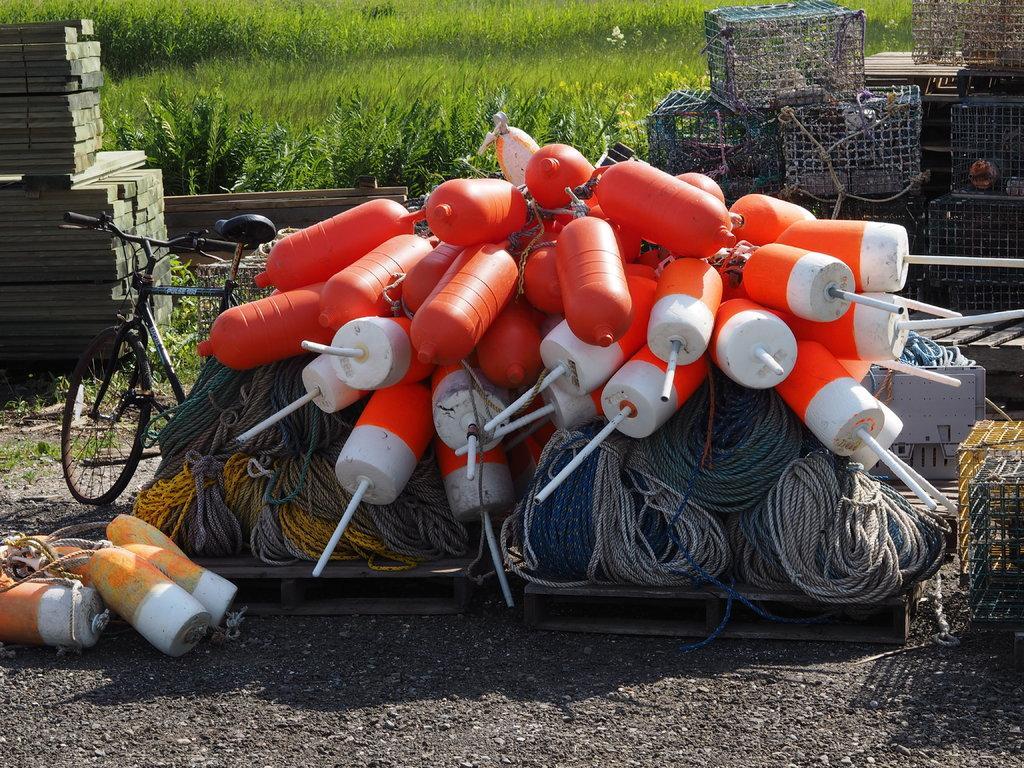Describe this image in one or two sentences. In the foreground of this image, there are few objects, ropes, mesh boxes, wooden block, a cycle and the grass at the top. 